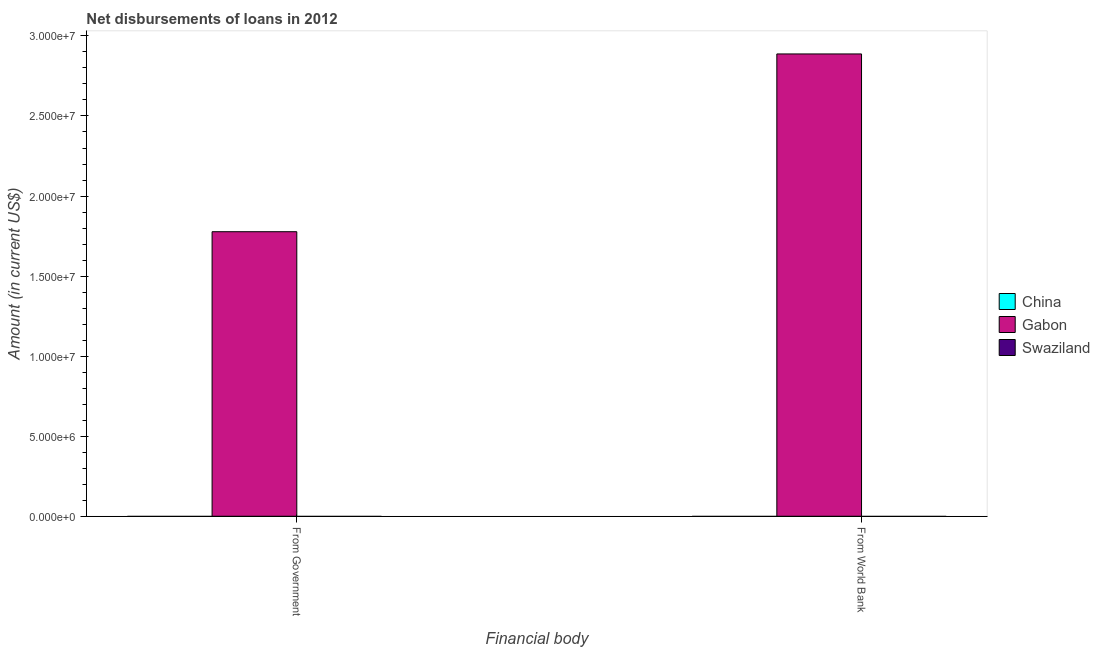Are the number of bars on each tick of the X-axis equal?
Ensure brevity in your answer.  Yes. What is the label of the 1st group of bars from the left?
Offer a terse response. From Government. What is the net disbursements of loan from government in Gabon?
Provide a short and direct response. 1.78e+07. Across all countries, what is the maximum net disbursements of loan from government?
Provide a succinct answer. 1.78e+07. Across all countries, what is the minimum net disbursements of loan from world bank?
Your answer should be compact. 0. In which country was the net disbursements of loan from government maximum?
Give a very brief answer. Gabon. What is the total net disbursements of loan from government in the graph?
Give a very brief answer. 1.78e+07. What is the average net disbursements of loan from world bank per country?
Give a very brief answer. 9.62e+06. What is the difference between the net disbursements of loan from world bank and net disbursements of loan from government in Gabon?
Provide a succinct answer. 1.11e+07. In how many countries, is the net disbursements of loan from world bank greater than 14000000 US$?
Your answer should be compact. 1. How many legend labels are there?
Provide a succinct answer. 3. How are the legend labels stacked?
Offer a very short reply. Vertical. What is the title of the graph?
Your answer should be compact. Net disbursements of loans in 2012. What is the label or title of the X-axis?
Your response must be concise. Financial body. What is the label or title of the Y-axis?
Make the answer very short. Amount (in current US$). What is the Amount (in current US$) of China in From Government?
Your answer should be compact. 0. What is the Amount (in current US$) in Gabon in From Government?
Provide a succinct answer. 1.78e+07. What is the Amount (in current US$) in Gabon in From World Bank?
Your answer should be very brief. 2.89e+07. Across all Financial body, what is the maximum Amount (in current US$) of Gabon?
Provide a short and direct response. 2.89e+07. Across all Financial body, what is the minimum Amount (in current US$) of Gabon?
Your response must be concise. 1.78e+07. What is the total Amount (in current US$) of Gabon in the graph?
Ensure brevity in your answer.  4.66e+07. What is the difference between the Amount (in current US$) of Gabon in From Government and that in From World Bank?
Give a very brief answer. -1.11e+07. What is the average Amount (in current US$) of China per Financial body?
Make the answer very short. 0. What is the average Amount (in current US$) of Gabon per Financial body?
Your response must be concise. 2.33e+07. What is the ratio of the Amount (in current US$) of Gabon in From Government to that in From World Bank?
Provide a short and direct response. 0.62. What is the difference between the highest and the second highest Amount (in current US$) of Gabon?
Give a very brief answer. 1.11e+07. What is the difference between the highest and the lowest Amount (in current US$) in Gabon?
Your response must be concise. 1.11e+07. 